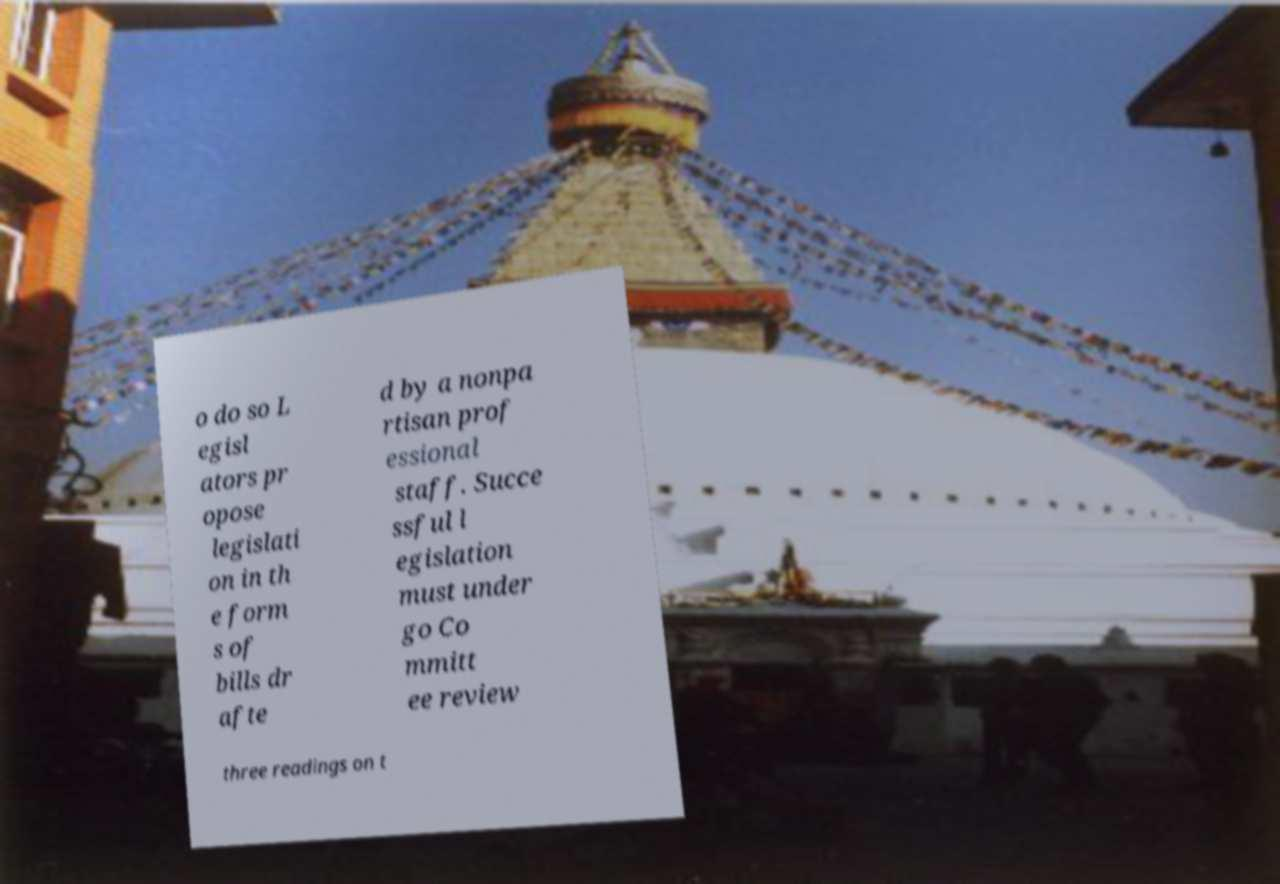Please read and relay the text visible in this image. What does it say? o do so L egisl ators pr opose legislati on in th e form s of bills dr afte d by a nonpa rtisan prof essional staff. Succe ssful l egislation must under go Co mmitt ee review three readings on t 